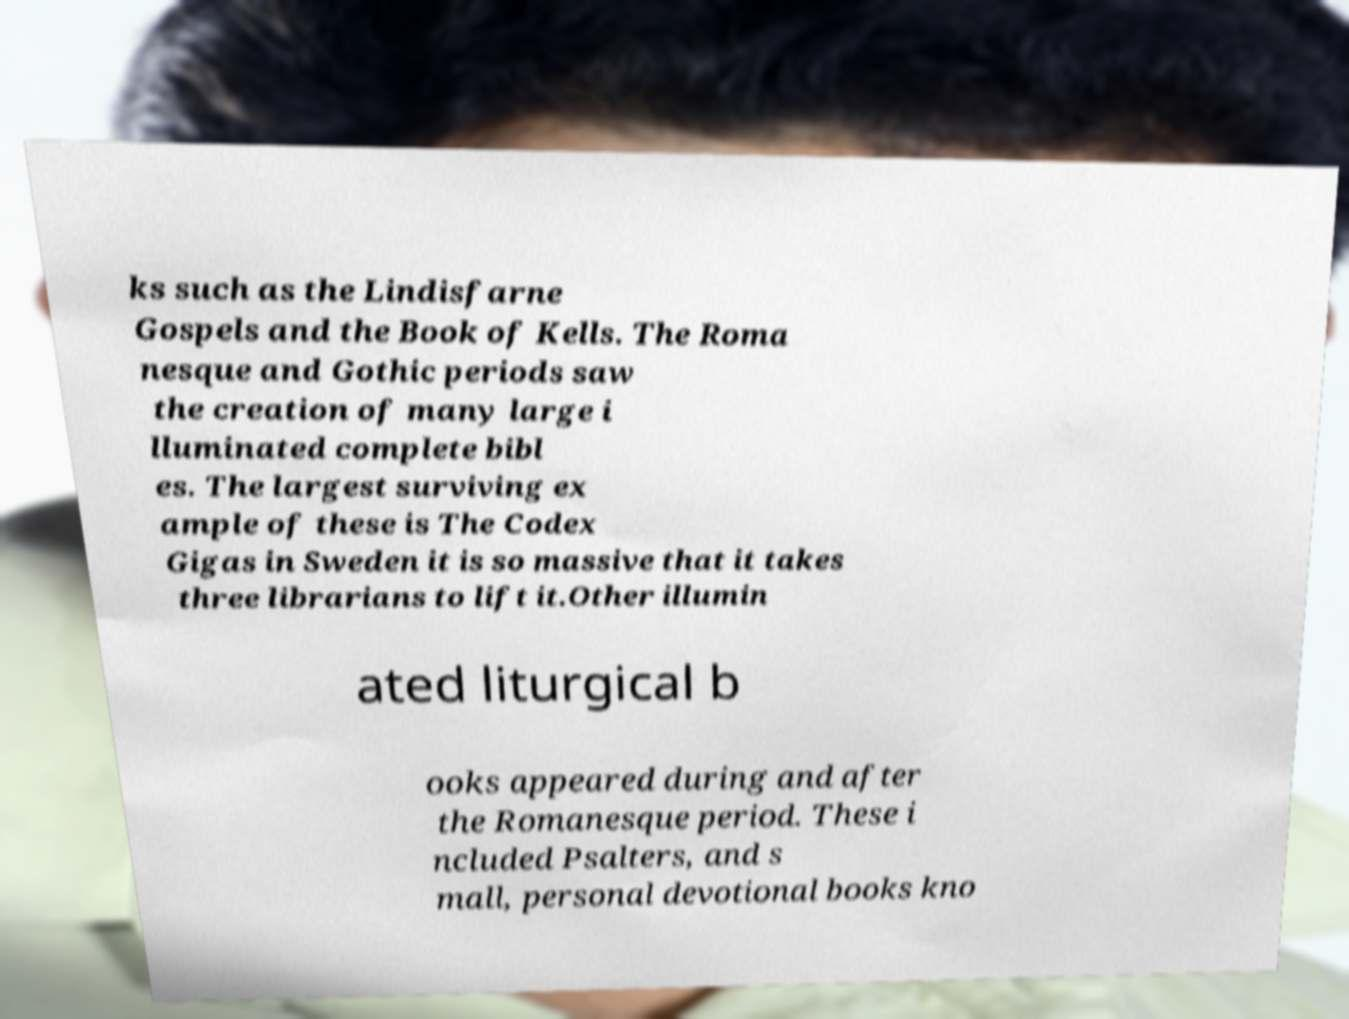Please read and relay the text visible in this image. What does it say? ks such as the Lindisfarne Gospels and the Book of Kells. The Roma nesque and Gothic periods saw the creation of many large i lluminated complete bibl es. The largest surviving ex ample of these is The Codex Gigas in Sweden it is so massive that it takes three librarians to lift it.Other illumin ated liturgical b ooks appeared during and after the Romanesque period. These i ncluded Psalters, and s mall, personal devotional books kno 